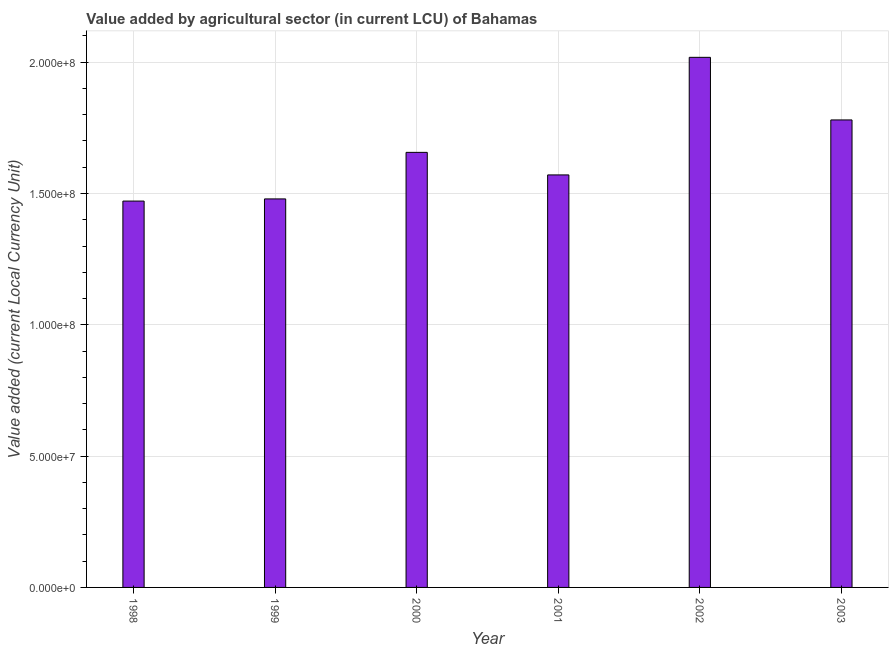Does the graph contain any zero values?
Your answer should be compact. No. Does the graph contain grids?
Offer a terse response. Yes. What is the title of the graph?
Your response must be concise. Value added by agricultural sector (in current LCU) of Bahamas. What is the label or title of the X-axis?
Your response must be concise. Year. What is the label or title of the Y-axis?
Your answer should be very brief. Value added (current Local Currency Unit). What is the value added by agriculture sector in 1998?
Ensure brevity in your answer.  1.47e+08. Across all years, what is the maximum value added by agriculture sector?
Ensure brevity in your answer.  2.02e+08. Across all years, what is the minimum value added by agriculture sector?
Give a very brief answer. 1.47e+08. What is the sum of the value added by agriculture sector?
Ensure brevity in your answer.  9.98e+08. What is the difference between the value added by agriculture sector in 1999 and 2002?
Provide a short and direct response. -5.39e+07. What is the average value added by agriculture sector per year?
Your response must be concise. 1.66e+08. What is the median value added by agriculture sector?
Offer a terse response. 1.61e+08. In how many years, is the value added by agriculture sector greater than 190000000 LCU?
Your response must be concise. 1. Do a majority of the years between 2000 and 2001 (inclusive) have value added by agriculture sector greater than 190000000 LCU?
Offer a very short reply. No. What is the ratio of the value added by agriculture sector in 2001 to that in 2002?
Keep it short and to the point. 0.78. Is the value added by agriculture sector in 2000 less than that in 2002?
Your answer should be compact. Yes. Is the difference between the value added by agriculture sector in 2001 and 2002 greater than the difference between any two years?
Your answer should be very brief. No. What is the difference between the highest and the second highest value added by agriculture sector?
Offer a terse response. 2.38e+07. Is the sum of the value added by agriculture sector in 2002 and 2003 greater than the maximum value added by agriculture sector across all years?
Offer a very short reply. Yes. What is the difference between the highest and the lowest value added by agriculture sector?
Make the answer very short. 5.47e+07. In how many years, is the value added by agriculture sector greater than the average value added by agriculture sector taken over all years?
Make the answer very short. 2. Are all the bars in the graph horizontal?
Make the answer very short. No. How many years are there in the graph?
Provide a short and direct response. 6. Are the values on the major ticks of Y-axis written in scientific E-notation?
Your answer should be very brief. Yes. What is the Value added (current Local Currency Unit) in 1998?
Make the answer very short. 1.47e+08. What is the Value added (current Local Currency Unit) in 1999?
Offer a terse response. 1.48e+08. What is the Value added (current Local Currency Unit) of 2000?
Ensure brevity in your answer.  1.66e+08. What is the Value added (current Local Currency Unit) of 2001?
Your response must be concise. 1.57e+08. What is the Value added (current Local Currency Unit) in 2002?
Your response must be concise. 2.02e+08. What is the Value added (current Local Currency Unit) in 2003?
Make the answer very short. 1.78e+08. What is the difference between the Value added (current Local Currency Unit) in 1998 and 1999?
Offer a terse response. -8.26e+05. What is the difference between the Value added (current Local Currency Unit) in 1998 and 2000?
Give a very brief answer. -1.85e+07. What is the difference between the Value added (current Local Currency Unit) in 1998 and 2001?
Provide a succinct answer. -9.96e+06. What is the difference between the Value added (current Local Currency Unit) in 1998 and 2002?
Your answer should be compact. -5.47e+07. What is the difference between the Value added (current Local Currency Unit) in 1998 and 2003?
Offer a terse response. -3.09e+07. What is the difference between the Value added (current Local Currency Unit) in 1999 and 2000?
Offer a terse response. -1.77e+07. What is the difference between the Value added (current Local Currency Unit) in 1999 and 2001?
Provide a succinct answer. -9.13e+06. What is the difference between the Value added (current Local Currency Unit) in 1999 and 2002?
Ensure brevity in your answer.  -5.39e+07. What is the difference between the Value added (current Local Currency Unit) in 1999 and 2003?
Provide a succinct answer. -3.01e+07. What is the difference between the Value added (current Local Currency Unit) in 2000 and 2001?
Give a very brief answer. 8.59e+06. What is the difference between the Value added (current Local Currency Unit) in 2000 and 2002?
Ensure brevity in your answer.  -3.62e+07. What is the difference between the Value added (current Local Currency Unit) in 2000 and 2003?
Offer a terse response. -1.24e+07. What is the difference between the Value added (current Local Currency Unit) in 2001 and 2002?
Make the answer very short. -4.48e+07. What is the difference between the Value added (current Local Currency Unit) in 2001 and 2003?
Make the answer very short. -2.09e+07. What is the difference between the Value added (current Local Currency Unit) in 2002 and 2003?
Your answer should be very brief. 2.38e+07. What is the ratio of the Value added (current Local Currency Unit) in 1998 to that in 2000?
Your response must be concise. 0.89. What is the ratio of the Value added (current Local Currency Unit) in 1998 to that in 2001?
Your answer should be very brief. 0.94. What is the ratio of the Value added (current Local Currency Unit) in 1998 to that in 2002?
Your answer should be compact. 0.73. What is the ratio of the Value added (current Local Currency Unit) in 1998 to that in 2003?
Make the answer very short. 0.83. What is the ratio of the Value added (current Local Currency Unit) in 1999 to that in 2000?
Provide a short and direct response. 0.89. What is the ratio of the Value added (current Local Currency Unit) in 1999 to that in 2001?
Give a very brief answer. 0.94. What is the ratio of the Value added (current Local Currency Unit) in 1999 to that in 2002?
Give a very brief answer. 0.73. What is the ratio of the Value added (current Local Currency Unit) in 1999 to that in 2003?
Offer a very short reply. 0.83. What is the ratio of the Value added (current Local Currency Unit) in 2000 to that in 2001?
Ensure brevity in your answer.  1.05. What is the ratio of the Value added (current Local Currency Unit) in 2000 to that in 2002?
Ensure brevity in your answer.  0.82. What is the ratio of the Value added (current Local Currency Unit) in 2000 to that in 2003?
Provide a succinct answer. 0.93. What is the ratio of the Value added (current Local Currency Unit) in 2001 to that in 2002?
Offer a terse response. 0.78. What is the ratio of the Value added (current Local Currency Unit) in 2001 to that in 2003?
Make the answer very short. 0.88. What is the ratio of the Value added (current Local Currency Unit) in 2002 to that in 2003?
Offer a terse response. 1.13. 